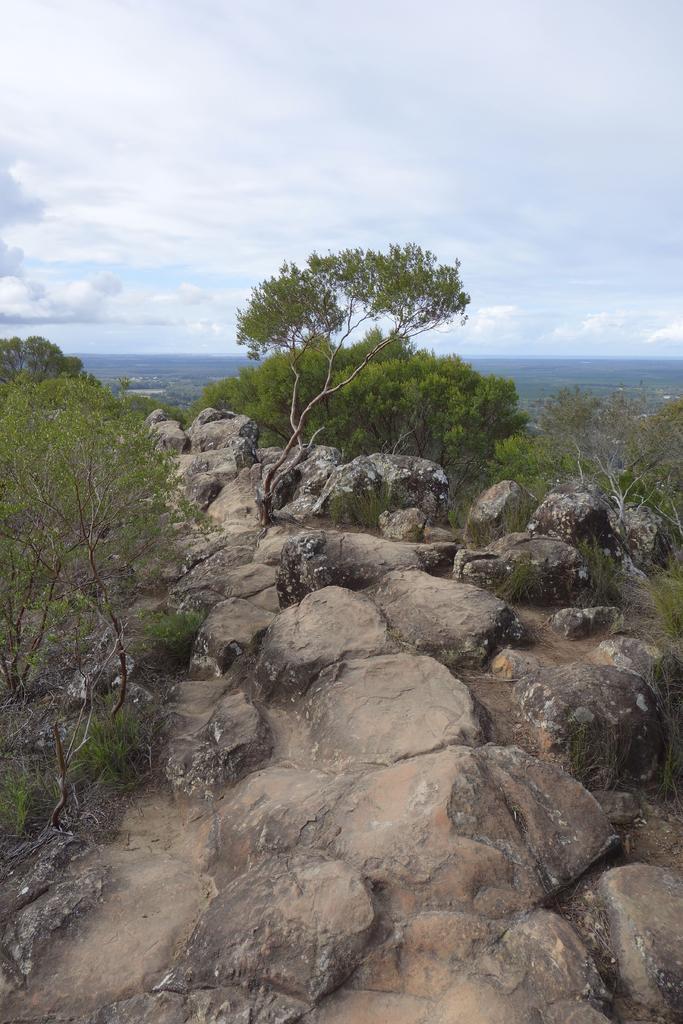Describe this image in one or two sentences. Here we can see rocks and trees. In the background there is sky with clouds. 